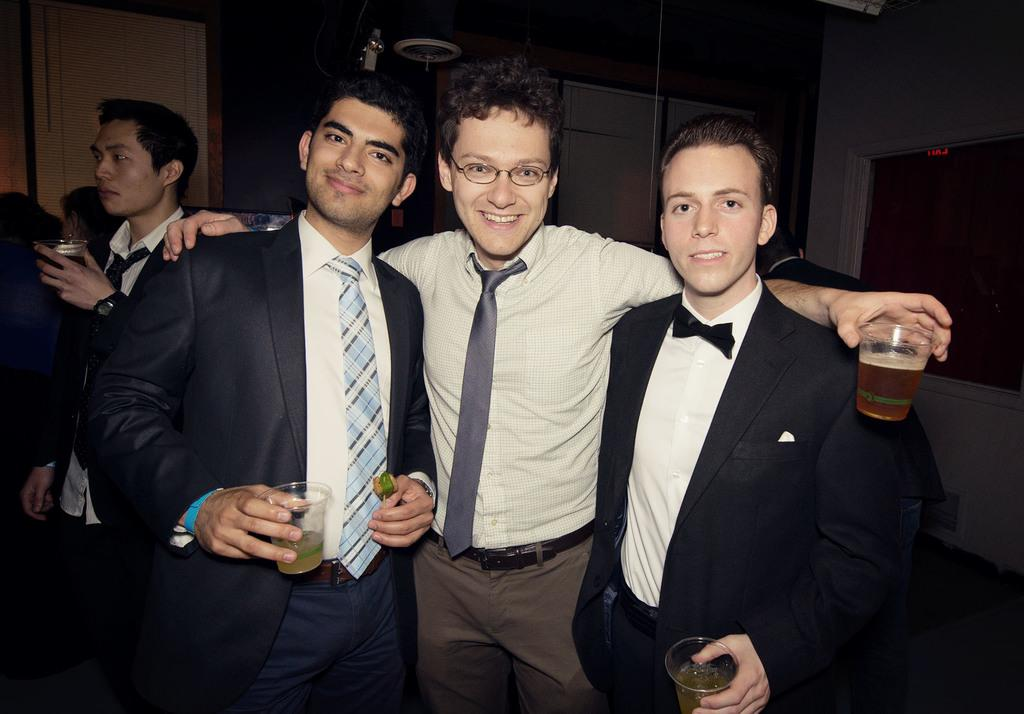How many people are in the image? There are three people in the front of the image. What are the people holding in the image? The people are holding glasses. What can be seen in the background of the image? There is a wall in the background of the image. What type of lamp is being used for the action in the image? There is no lamp or action present in the image; it features three people holding glasses. 